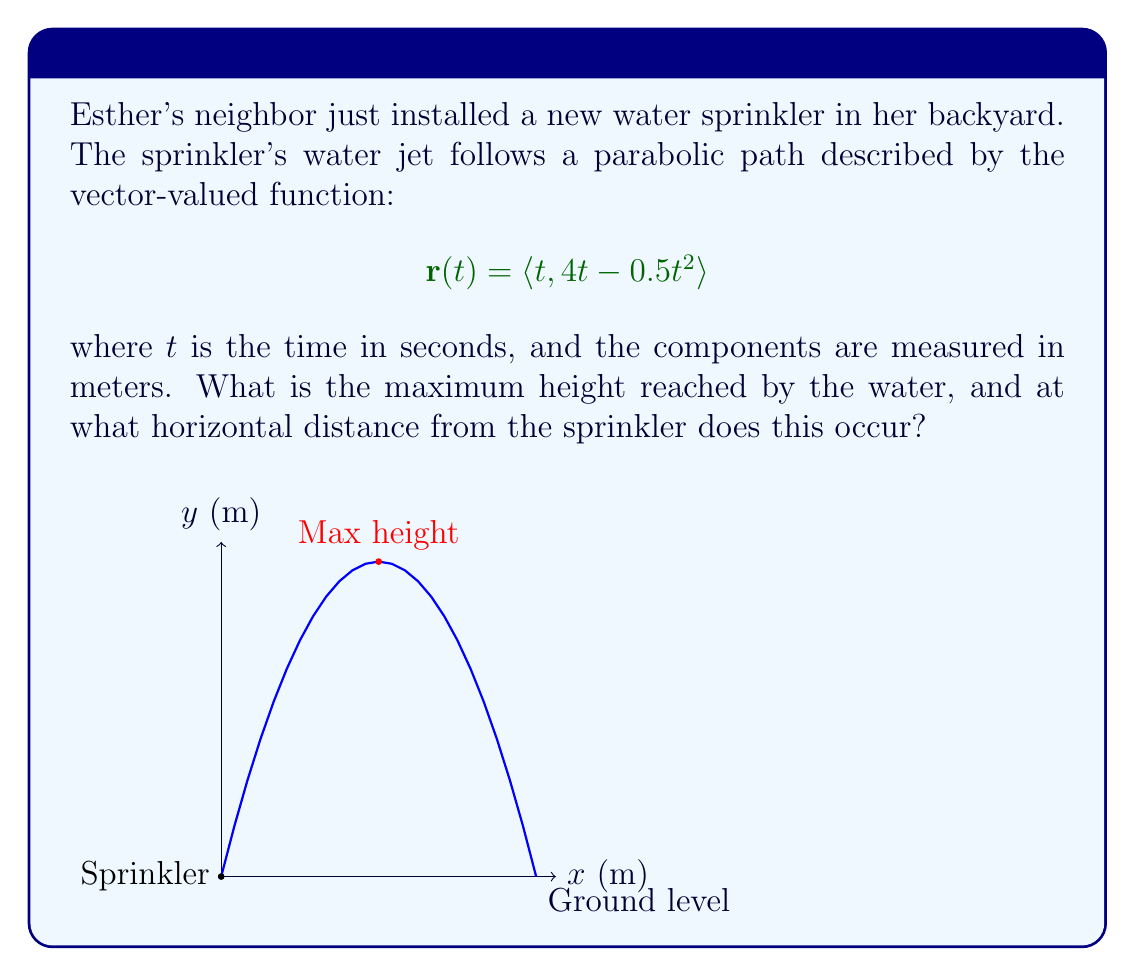Show me your answer to this math problem. Let's approach this step-by-step:

1) The height of the water is given by the y-component of the vector function:
   $$y(t) = 4t - 0.5t^2$$

2) To find the maximum height, we need to find where the derivative of y(t) is zero:
   $$\frac{dy}{dt} = 4 - t$$
   
3) Set this equal to zero and solve:
   $$4 - t = 0$$
   $$t = 4$$

4) This tells us that the maximum height occurs when t = 4 seconds.

5) To find the maximum height, we plug t = 4 back into the original function:
   $$y(4) = 4(4) - 0.5(4)^2 = 16 - 8 = 8$$

6) So the maximum height is 8 meters.

7) To find the horizontal distance, we use the x-component of the vector function:
   $$x(t) = t$$

8) Since we know t = 4 at the maximum height, the horizontal distance is also 4 meters.
Answer: Maximum height: 8 meters; Horizontal distance: 4 meters 